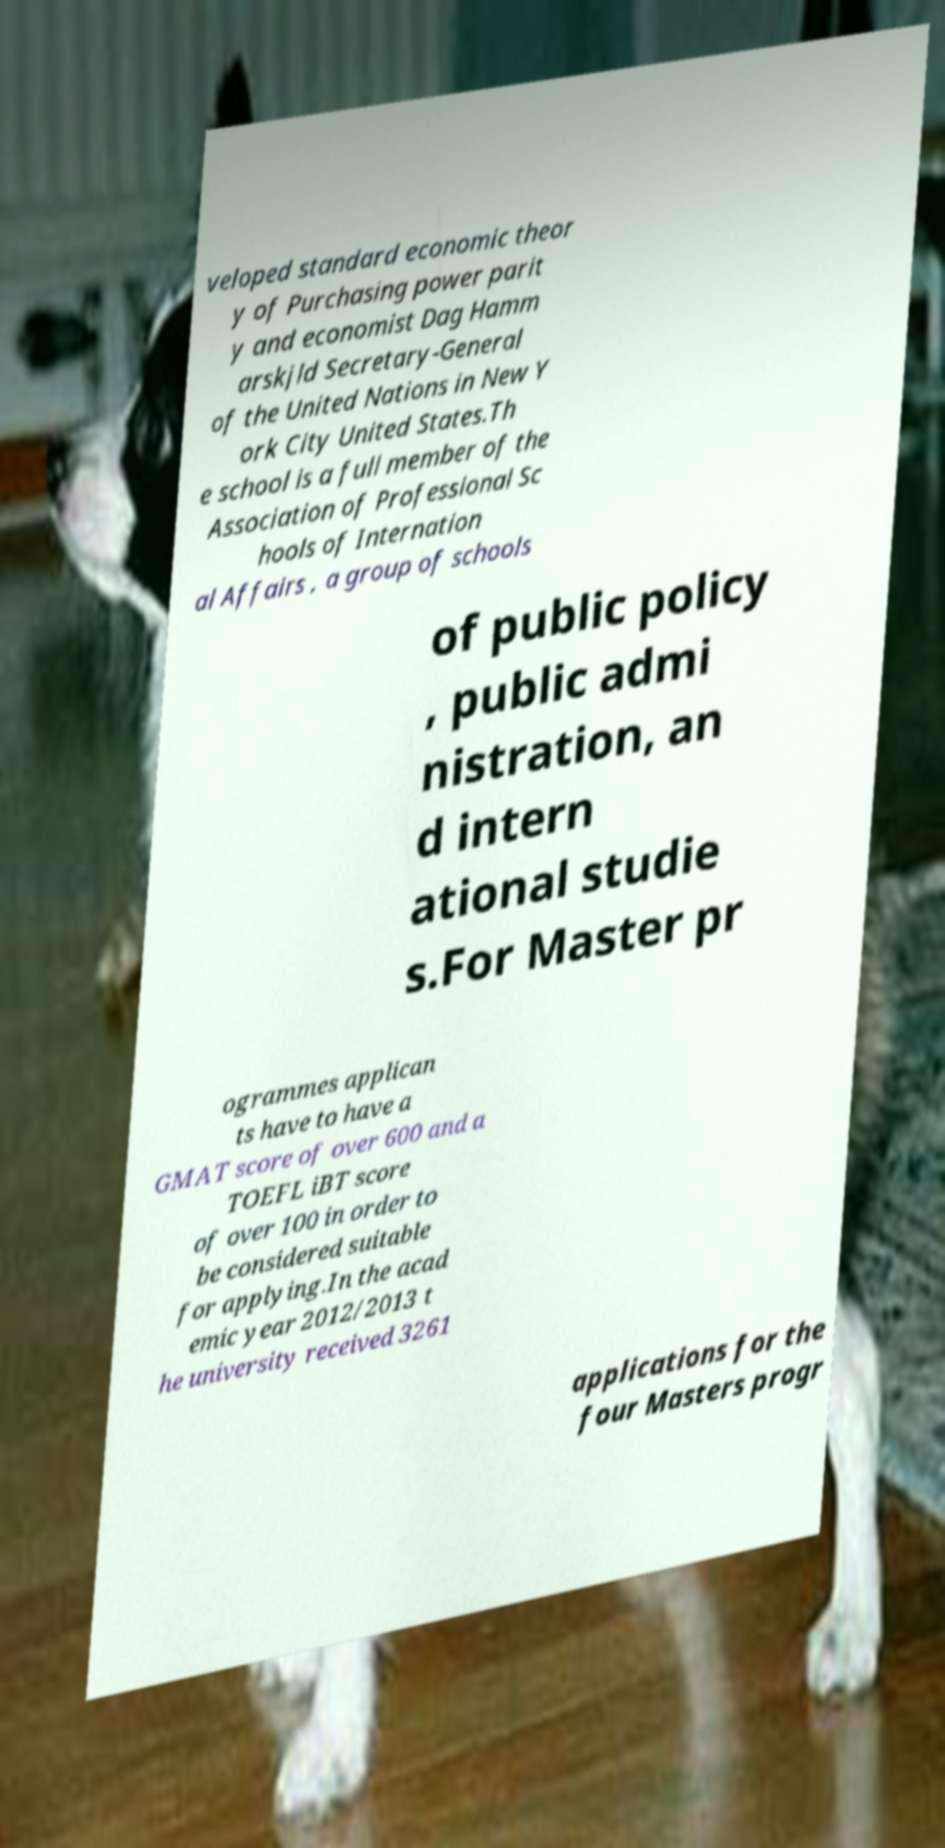Can you read and provide the text displayed in the image?This photo seems to have some interesting text. Can you extract and type it out for me? veloped standard economic theor y of Purchasing power parit y and economist Dag Hamm arskjld Secretary-General of the United Nations in New Y ork City United States.Th e school is a full member of the Association of Professional Sc hools of Internation al Affairs , a group of schools of public policy , public admi nistration, an d intern ational studie s.For Master pr ogrammes applican ts have to have a GMAT score of over 600 and a TOEFL iBT score of over 100 in order to be considered suitable for applying.In the acad emic year 2012/2013 t he university received 3261 applications for the four Masters progr 